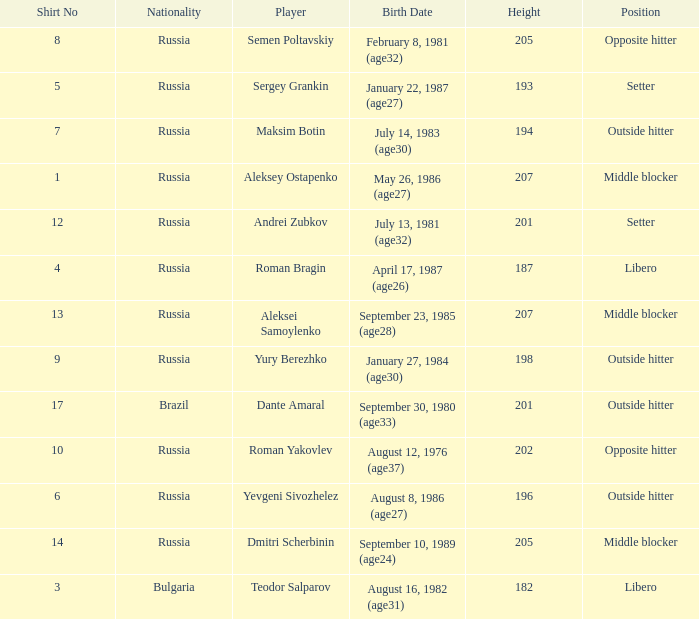How tall is Maksim Botin?  194.0. 